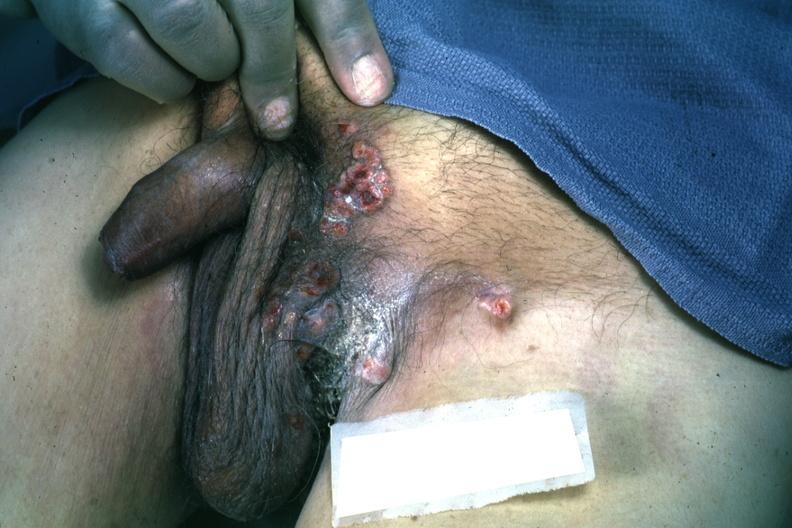what does this image show?
Answer the question using a single word or phrase. Multiple ulcerative lesions rectum primary excellent 